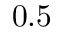Convert formula to latex. <formula><loc_0><loc_0><loc_500><loc_500>0 . 5</formula> 